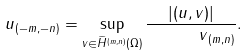<formula> <loc_0><loc_0><loc_500><loc_500>\| u \| _ { ( - m , - n ) } = \sup _ { v \in \widetilde { H } ^ { ( m , n ) } ( \Omega ) } \frac { | ( u , v ) | } { \text { } \text { } \text { } \text { } \text { } \| v \| _ { ( m , n ) } } .</formula> 